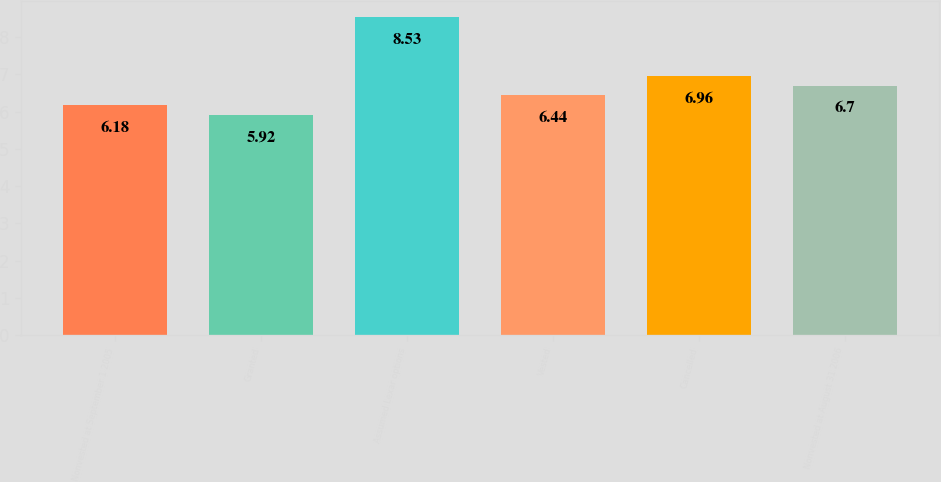<chart> <loc_0><loc_0><loc_500><loc_500><bar_chart><fcel>Nonvested at September 1 2005<fcel>Granted<fcel>Assumed Lexar options<fcel>Vested<fcel>Cancelled<fcel>Nonvested at August 31 2006<nl><fcel>6.18<fcel>5.92<fcel>8.53<fcel>6.44<fcel>6.96<fcel>6.7<nl></chart> 